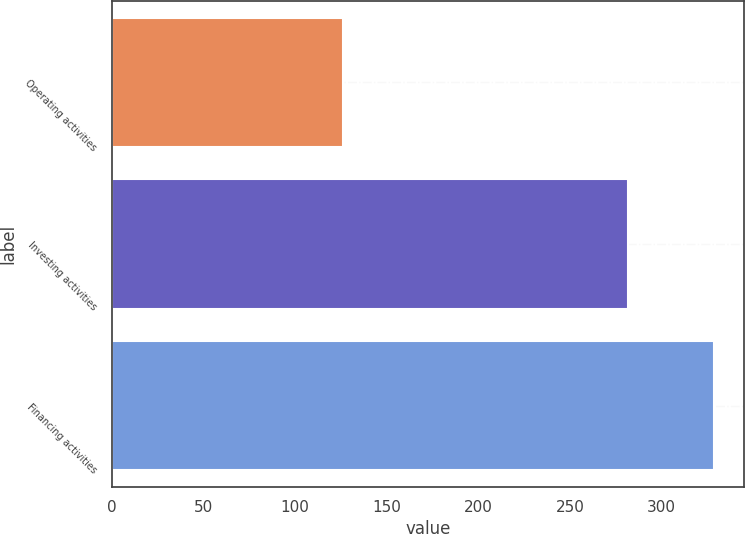<chart> <loc_0><loc_0><loc_500><loc_500><bar_chart><fcel>Operating activities<fcel>Investing activities<fcel>Financing activities<nl><fcel>125.9<fcel>281.5<fcel>328.6<nl></chart> 